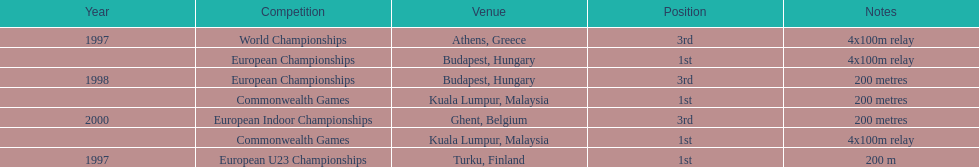What was the only competition won in belgium? European Indoor Championships. 